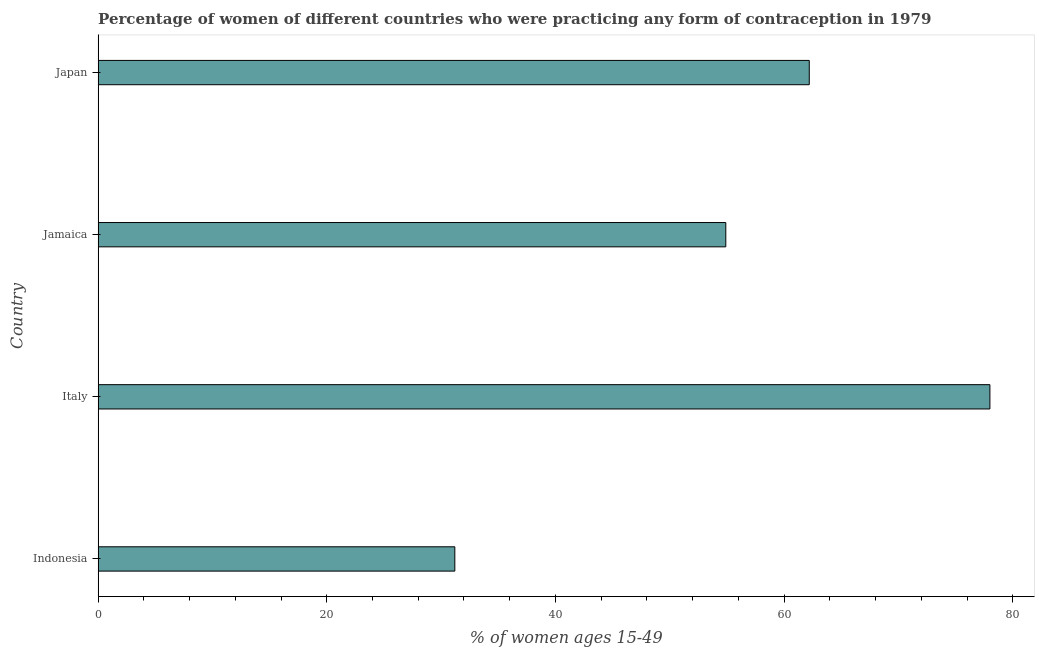Does the graph contain any zero values?
Give a very brief answer. No. Does the graph contain grids?
Your response must be concise. No. What is the title of the graph?
Make the answer very short. Percentage of women of different countries who were practicing any form of contraception in 1979. What is the label or title of the X-axis?
Offer a terse response. % of women ages 15-49. What is the label or title of the Y-axis?
Your answer should be compact. Country. What is the contraceptive prevalence in Jamaica?
Offer a very short reply. 54.9. Across all countries, what is the maximum contraceptive prevalence?
Ensure brevity in your answer.  78. Across all countries, what is the minimum contraceptive prevalence?
Offer a very short reply. 31.2. In which country was the contraceptive prevalence maximum?
Offer a very short reply. Italy. In which country was the contraceptive prevalence minimum?
Offer a terse response. Indonesia. What is the sum of the contraceptive prevalence?
Provide a succinct answer. 226.3. What is the difference between the contraceptive prevalence in Indonesia and Japan?
Your answer should be compact. -31. What is the average contraceptive prevalence per country?
Ensure brevity in your answer.  56.58. What is the median contraceptive prevalence?
Keep it short and to the point. 58.55. What is the ratio of the contraceptive prevalence in Indonesia to that in Japan?
Offer a very short reply. 0.5. Is the contraceptive prevalence in Indonesia less than that in Jamaica?
Your answer should be compact. Yes. What is the difference between the highest and the second highest contraceptive prevalence?
Offer a very short reply. 15.8. Is the sum of the contraceptive prevalence in Italy and Japan greater than the maximum contraceptive prevalence across all countries?
Give a very brief answer. Yes. What is the difference between the highest and the lowest contraceptive prevalence?
Your response must be concise. 46.8. Are all the bars in the graph horizontal?
Your answer should be compact. Yes. What is the % of women ages 15-49 in Indonesia?
Ensure brevity in your answer.  31.2. What is the % of women ages 15-49 of Jamaica?
Make the answer very short. 54.9. What is the % of women ages 15-49 of Japan?
Your answer should be very brief. 62.2. What is the difference between the % of women ages 15-49 in Indonesia and Italy?
Make the answer very short. -46.8. What is the difference between the % of women ages 15-49 in Indonesia and Jamaica?
Provide a succinct answer. -23.7. What is the difference between the % of women ages 15-49 in Indonesia and Japan?
Provide a short and direct response. -31. What is the difference between the % of women ages 15-49 in Italy and Jamaica?
Your response must be concise. 23.1. What is the difference between the % of women ages 15-49 in Jamaica and Japan?
Provide a short and direct response. -7.3. What is the ratio of the % of women ages 15-49 in Indonesia to that in Jamaica?
Provide a succinct answer. 0.57. What is the ratio of the % of women ages 15-49 in Indonesia to that in Japan?
Provide a short and direct response. 0.5. What is the ratio of the % of women ages 15-49 in Italy to that in Jamaica?
Offer a very short reply. 1.42. What is the ratio of the % of women ages 15-49 in Italy to that in Japan?
Your answer should be compact. 1.25. What is the ratio of the % of women ages 15-49 in Jamaica to that in Japan?
Keep it short and to the point. 0.88. 